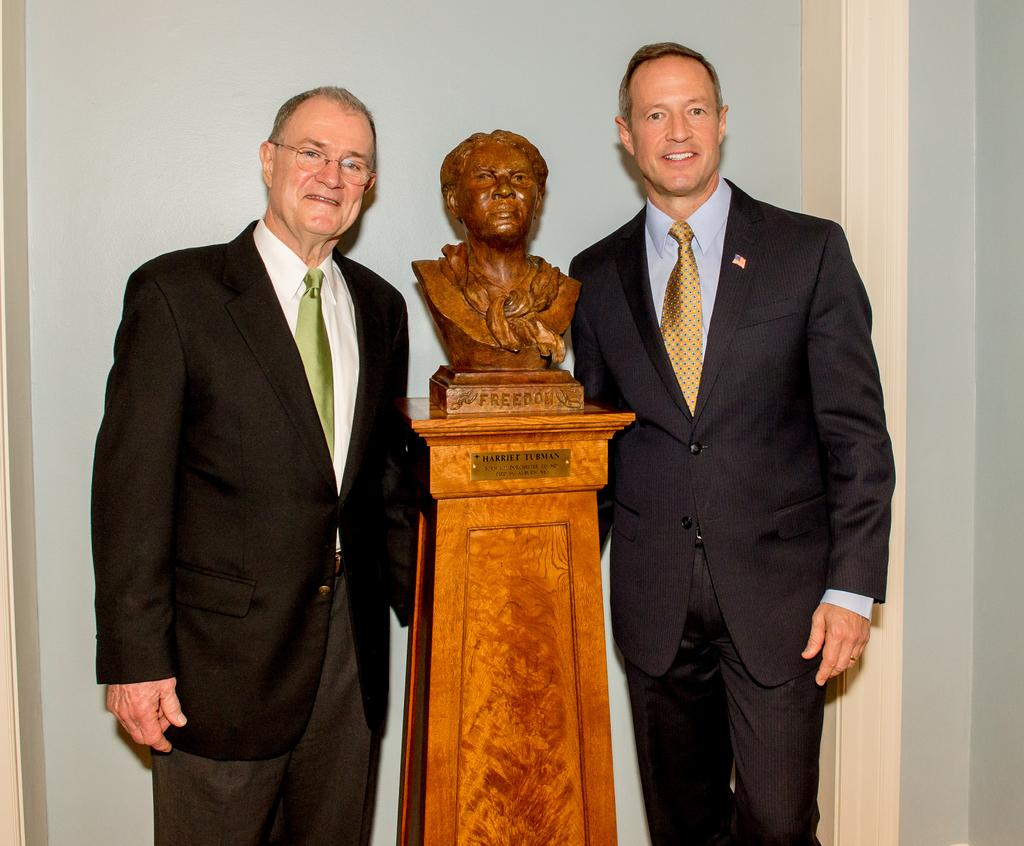How many people are in the image? There are two people in the image. What are the two people doing in the image? The two people are standing near a sculpture. What is the facial expression of the two people? The two people are smiling. What are the two people wearing in the image? They are wearing suits. What can be seen in the background of the image? There is a white wall in the background of the image. What type of nut is growing on the tree in the image? There is no tree or nut present in the image; it features two people standing near a sculpture. 